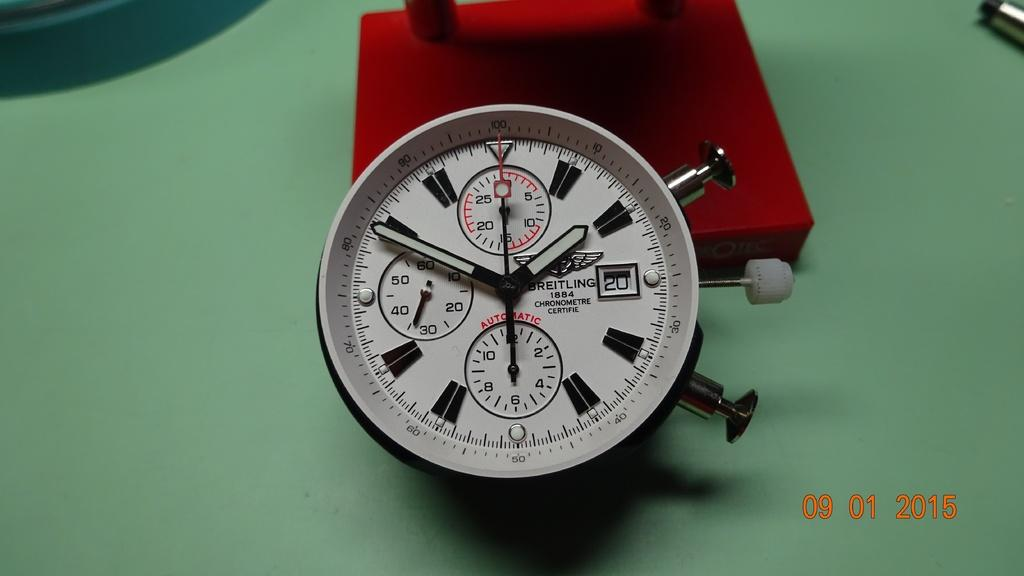<image>
Summarize the visual content of the image. A Breitling watch face is displayed near a red platform. 